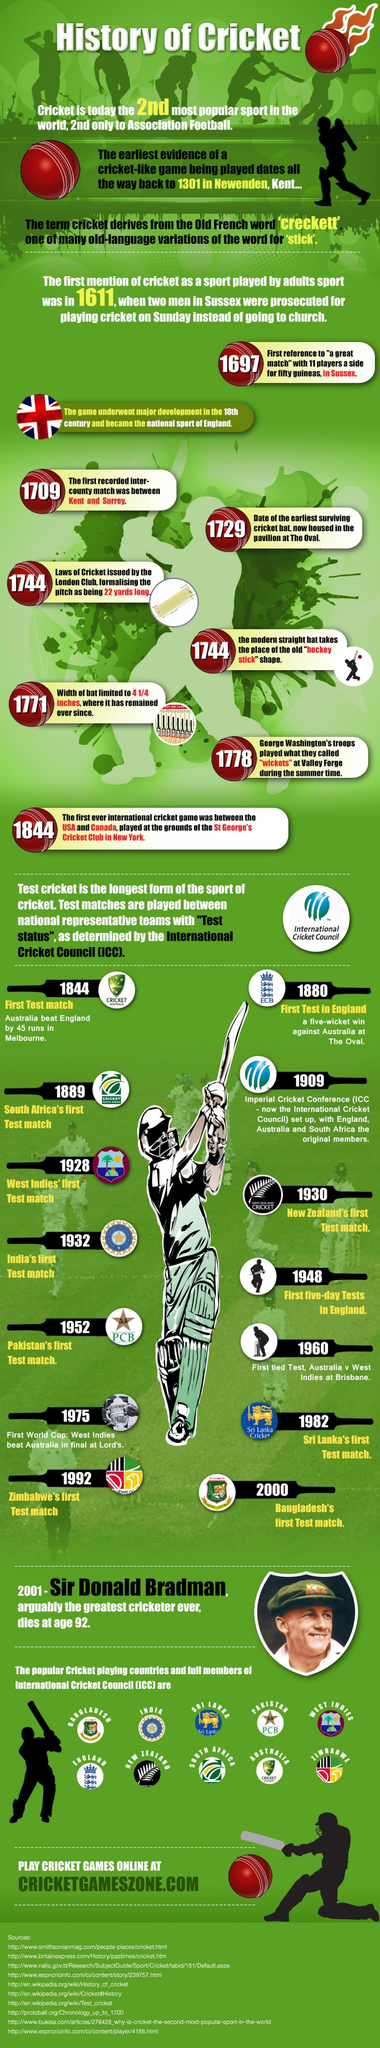Where was the first test match played?
Answer the question with a short phrase. Melbourne Which of these teams played it's first test match earlier - India, Sri Lanka or Pakistan? India How many full members of ICC are shown the infographic? 10 Which were the earliest teams in the ICC? England, Australia and South Africa Among the full members listed in the infographic, which country was the last to play it's first test match? Bangladesh 